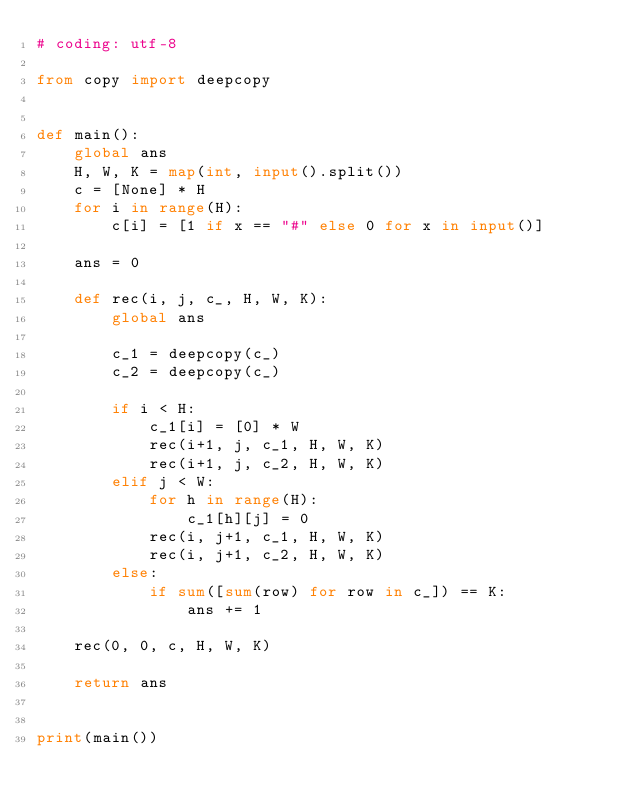<code> <loc_0><loc_0><loc_500><loc_500><_Python_># coding: utf-8

from copy import deepcopy


def main():
    global ans
    H, W, K = map(int, input().split())
    c = [None] * H
    for i in range(H):
        c[i] = [1 if x == "#" else 0 for x in input()]

    ans = 0

    def rec(i, j, c_, H, W, K):
        global ans

        c_1 = deepcopy(c_)
        c_2 = deepcopy(c_)

        if i < H:
            c_1[i] = [0] * W
            rec(i+1, j, c_1, H, W, K)
            rec(i+1, j, c_2, H, W, K)
        elif j < W:
            for h in range(H):
                c_1[h][j] = 0
            rec(i, j+1, c_1, H, W, K)
            rec(i, j+1, c_2, H, W, K)
        else:
            if sum([sum(row) for row in c_]) == K:
                ans += 1

    rec(0, 0, c, H, W, K)

    return ans


print(main())
</code> 